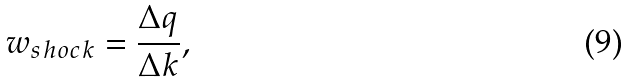<formula> <loc_0><loc_0><loc_500><loc_500>w _ { s h o c k } = \frac { \Delta q } { \Delta k } ,</formula> 